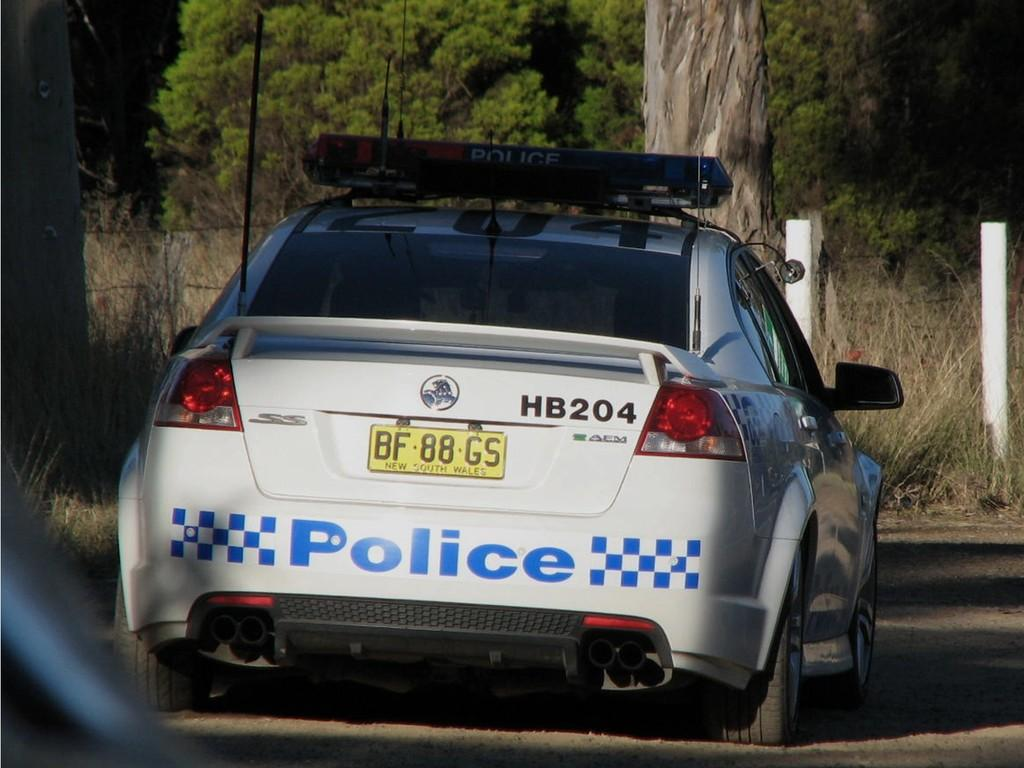Provide a one-sentence caption for the provided image. The police car has a license plate number of BF88GS. 